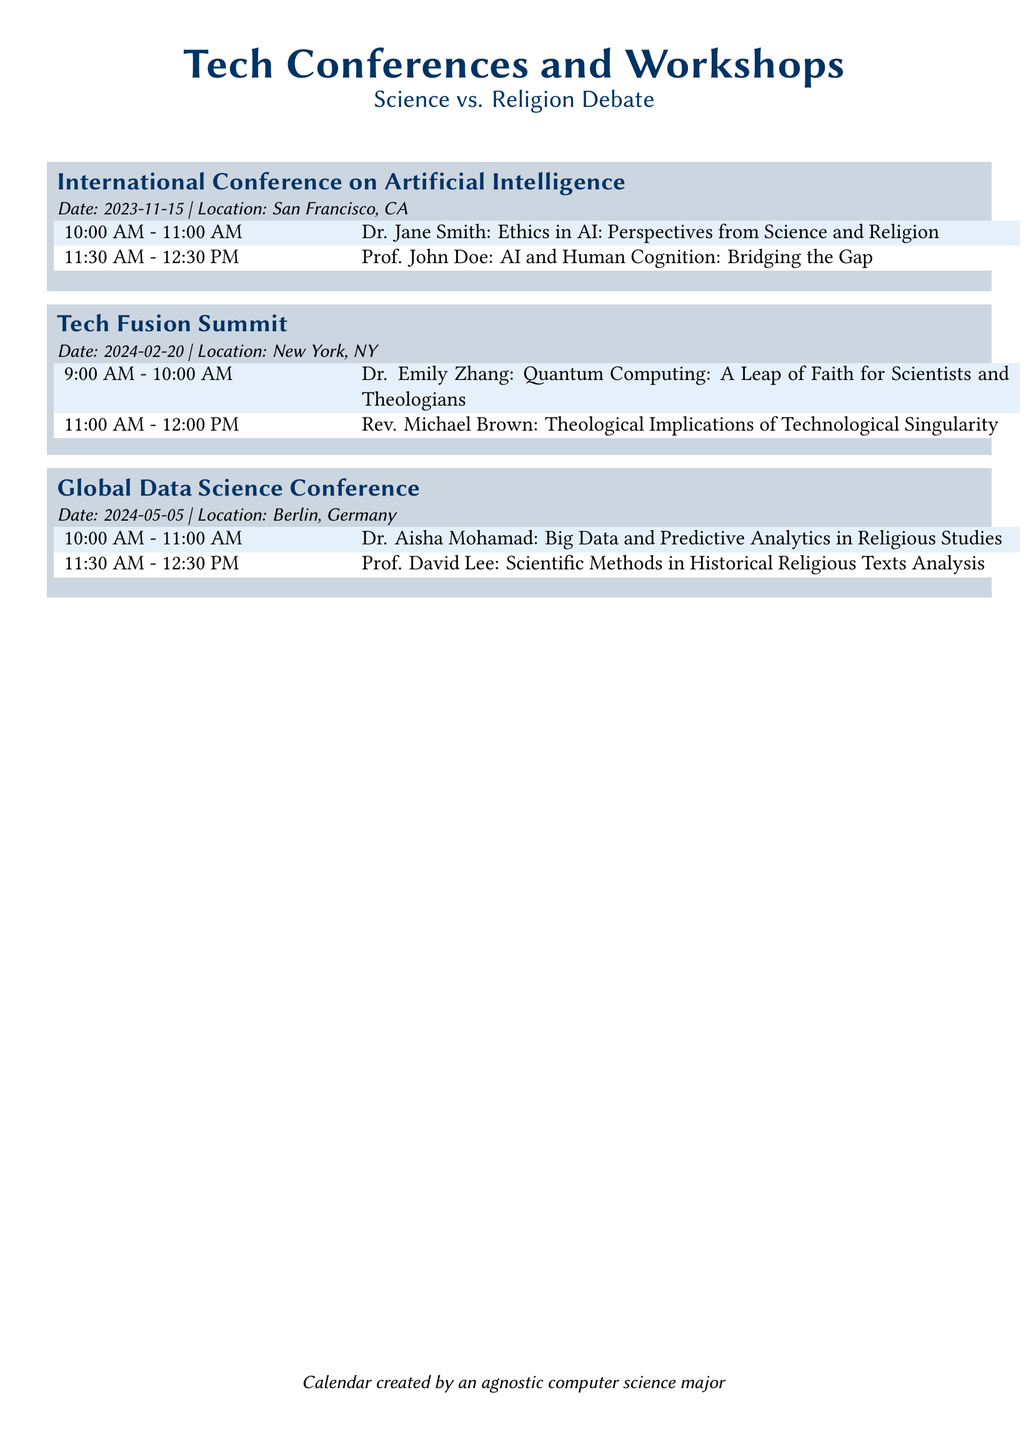what is the date of the International Conference on Artificial Intelligence? The date of the conference is stated directly in the event box for that conference.
Answer: 2023-11-15 who is speaking on ethics in AI? The speaker's name and topic are clearly listed under the schedule for the International Conference on Artificial Intelligence.
Answer: Dr. Jane Smith where is the Tech Fusion Summit taking place? The location for the Tech Fusion Summit is shown in the event box associated with that conference.
Answer: New York, NY which speaker discusses quantum computing? The name of the speaker discussing quantum computing is available in the schedule of the Tech Fusion Summit.
Answer: Dr. Emily Zhang what time does the session on big data start at the Global Data Science Conference? The start time is provided in the event box for the Global Data Science Conference.
Answer: 10:00 AM how many sessions are there in the International Conference on Artificial Intelligence? The total number of sessions can be determined by counting the entries in the schedule for that conference.
Answer: 2 what is the main theme of the discussions at the Tech Fusion Summit? The themes can be inferred by analyzing the topics of the speakers listed in the schedule.
Answer: Technological and theological implications who presents on the scientific methods in analyzing historical religious texts? This information is found under the schedule of the Global Data Science Conference.
Answer: Prof. David Lee what is the overall focus of the events listed in this document? The focus can be deduced from the titles and topics of the conferences and workshops listed.
Answer: Technology and Religion 